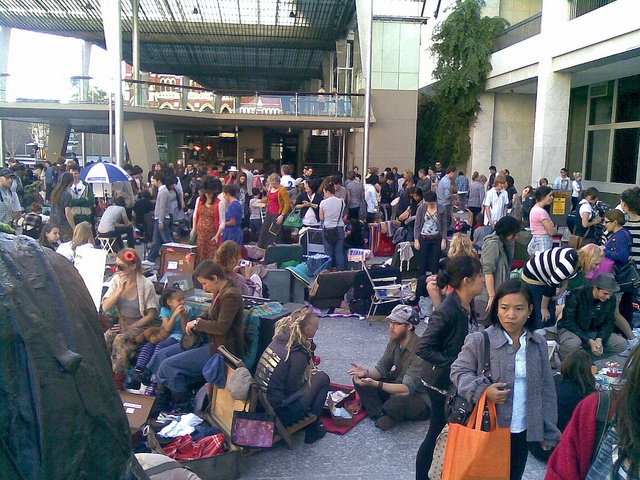Describe the objects in this image and their specific colors. I can see people in darkgray, black, gray, and navy tones, backpack in darkgray, black, gray, darkblue, and blue tones, people in darkgray, gray, black, and brown tones, people in darkgray, black, and gray tones, and people in darkgray, black, and gray tones in this image. 